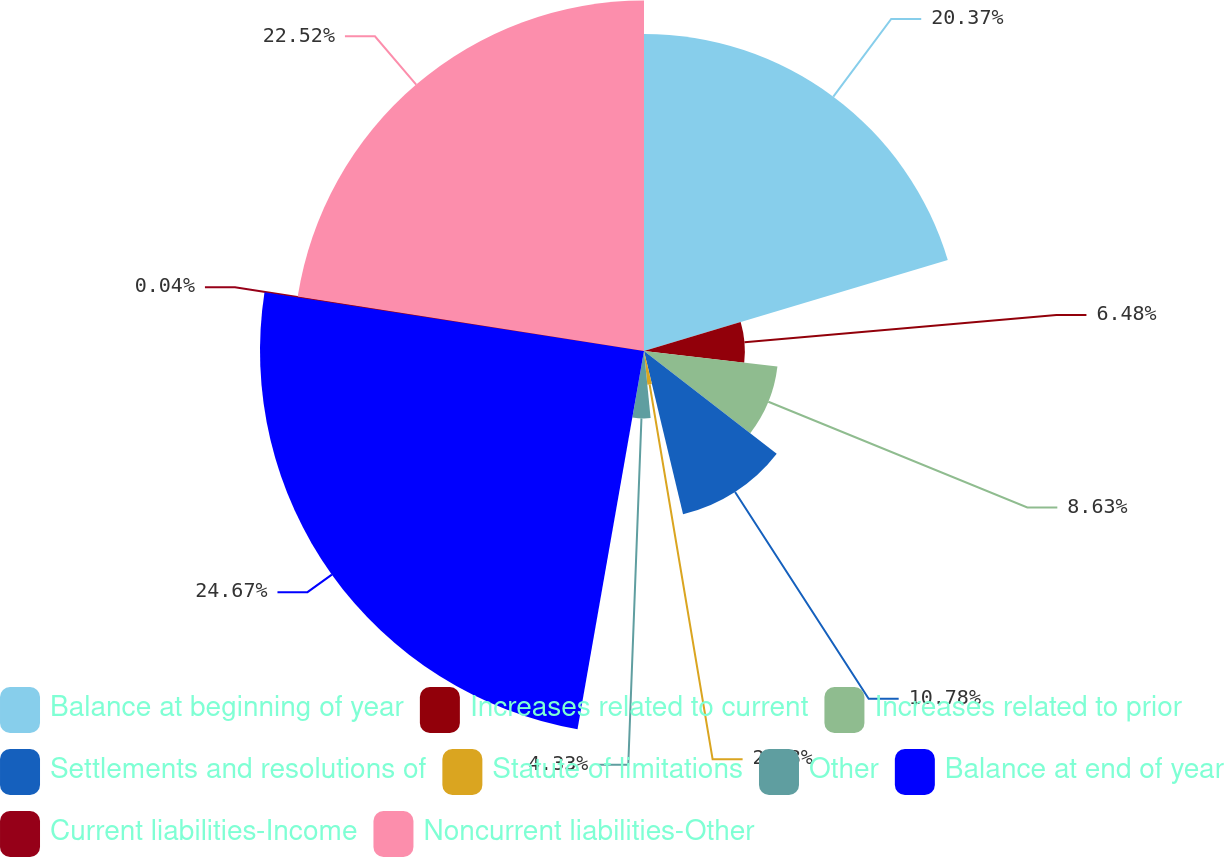<chart> <loc_0><loc_0><loc_500><loc_500><pie_chart><fcel>Balance at beginning of year<fcel>Increases related to current<fcel>Increases related to prior<fcel>Settlements and resolutions of<fcel>Statute of limitations<fcel>Other<fcel>Balance at end of year<fcel>Current liabilities-Income<fcel>Noncurrent liabilities-Other<nl><fcel>20.37%<fcel>6.48%<fcel>8.63%<fcel>10.78%<fcel>2.18%<fcel>4.33%<fcel>24.67%<fcel>0.04%<fcel>22.52%<nl></chart> 